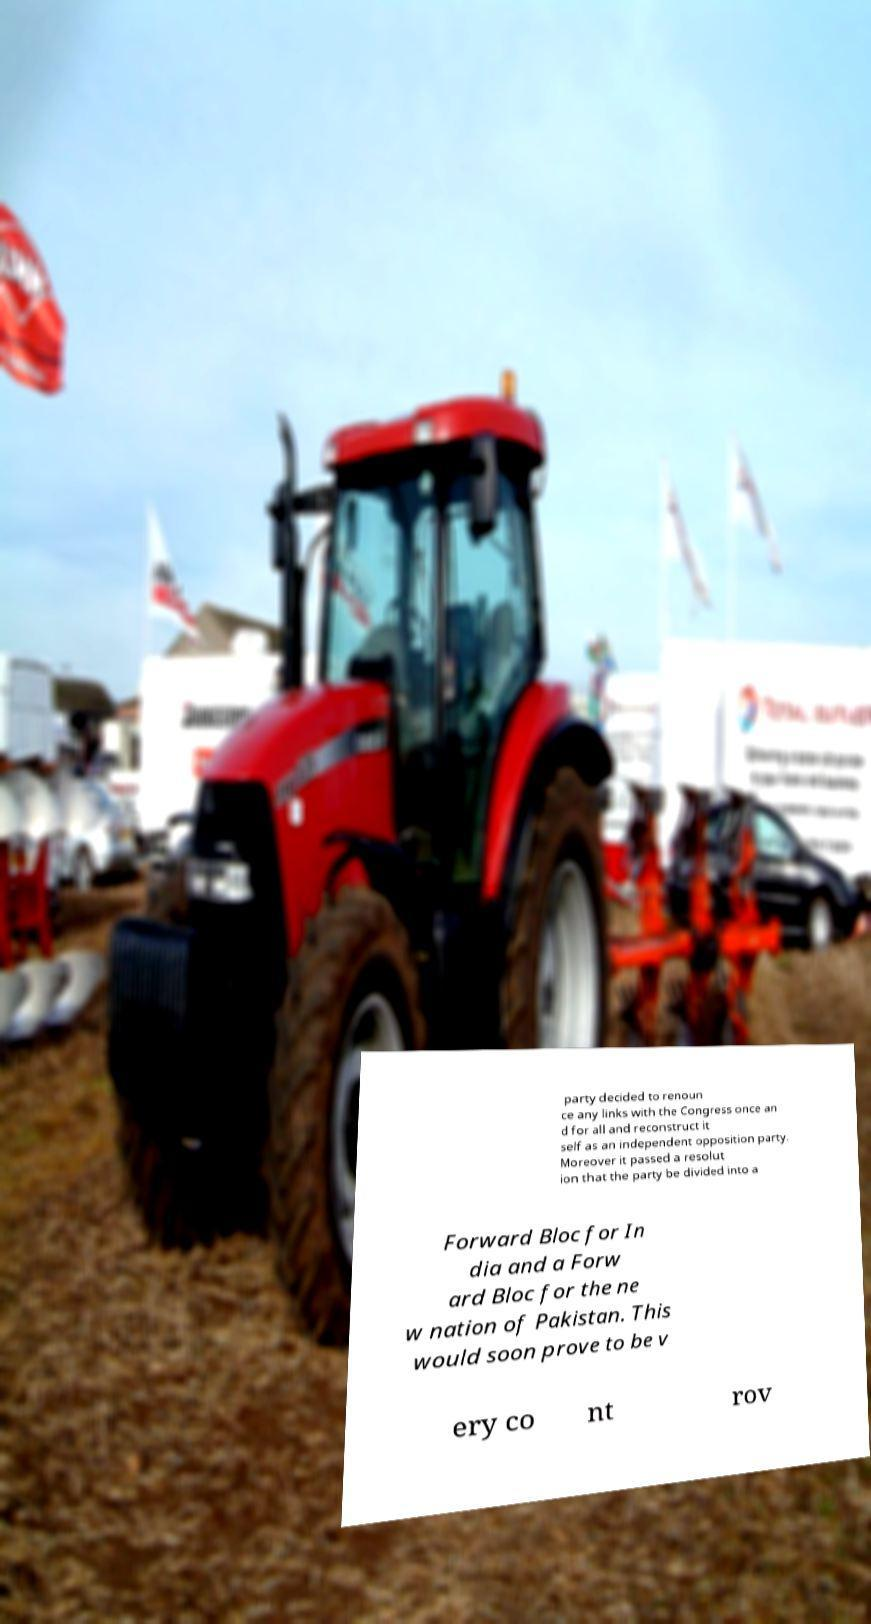Could you extract and type out the text from this image? party decided to renoun ce any links with the Congress once an d for all and reconstruct it self as an independent opposition party. Moreover it passed a resolut ion that the party be divided into a Forward Bloc for In dia and a Forw ard Bloc for the ne w nation of Pakistan. This would soon prove to be v ery co nt rov 